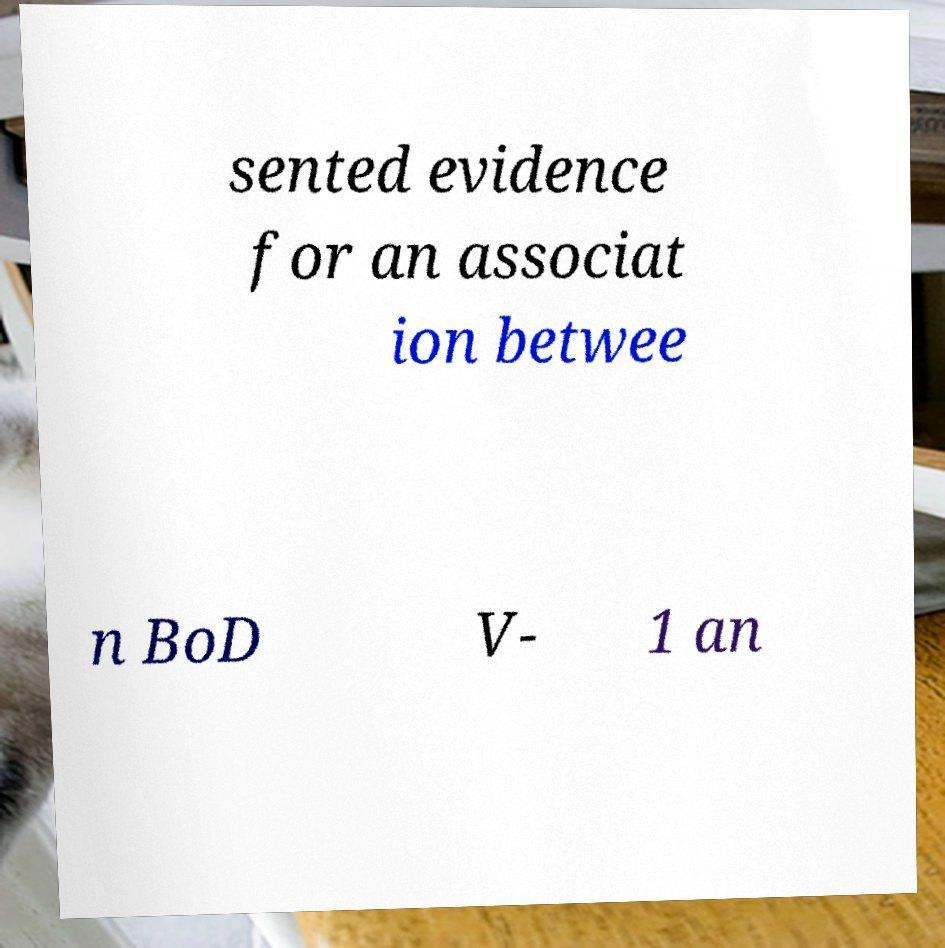What messages or text are displayed in this image? I need them in a readable, typed format. sented evidence for an associat ion betwee n BoD V- 1 an 